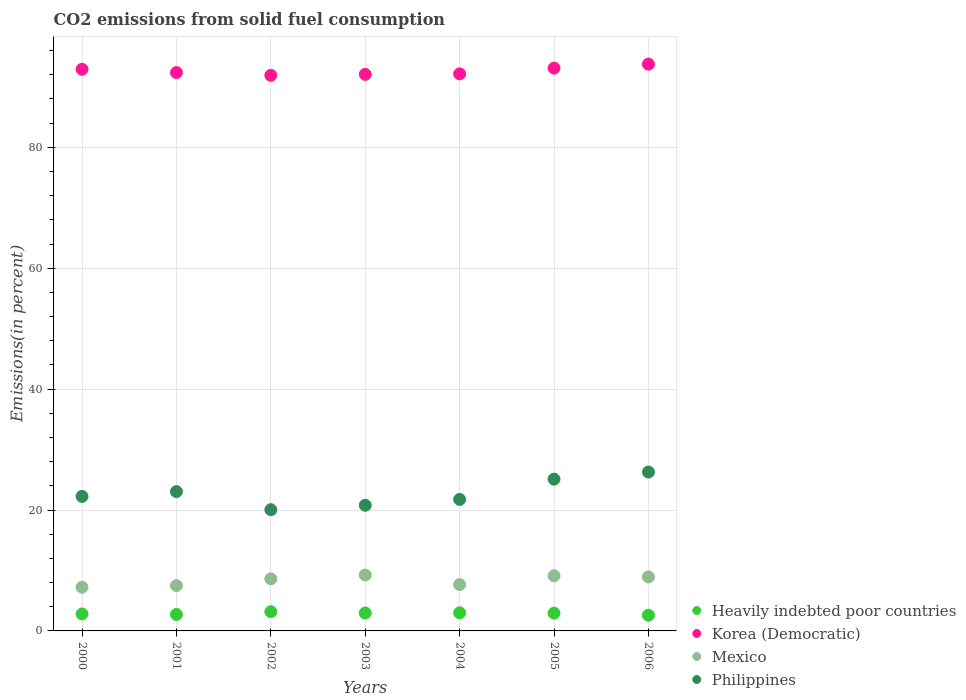How many different coloured dotlines are there?
Make the answer very short. 4. Is the number of dotlines equal to the number of legend labels?
Provide a succinct answer. Yes. What is the total CO2 emitted in Korea (Democratic) in 2002?
Keep it short and to the point. 91.92. Across all years, what is the maximum total CO2 emitted in Philippines?
Provide a succinct answer. 26.29. Across all years, what is the minimum total CO2 emitted in Philippines?
Your answer should be very brief. 20.06. What is the total total CO2 emitted in Philippines in the graph?
Your answer should be very brief. 159.3. What is the difference between the total CO2 emitted in Heavily indebted poor countries in 2001 and that in 2004?
Keep it short and to the point. -0.27. What is the difference between the total CO2 emitted in Heavily indebted poor countries in 2005 and the total CO2 emitted in Mexico in 2000?
Keep it short and to the point. -4.29. What is the average total CO2 emitted in Mexico per year?
Offer a very short reply. 8.33. In the year 2002, what is the difference between the total CO2 emitted in Philippines and total CO2 emitted in Mexico?
Offer a terse response. 11.44. What is the ratio of the total CO2 emitted in Heavily indebted poor countries in 2000 to that in 2003?
Your response must be concise. 0.95. What is the difference between the highest and the second highest total CO2 emitted in Korea (Democratic)?
Your answer should be very brief. 0.66. What is the difference between the highest and the lowest total CO2 emitted in Heavily indebted poor countries?
Make the answer very short. 0.58. Is the sum of the total CO2 emitted in Korea (Democratic) in 2001 and 2003 greater than the maximum total CO2 emitted in Heavily indebted poor countries across all years?
Give a very brief answer. Yes. Is it the case that in every year, the sum of the total CO2 emitted in Mexico and total CO2 emitted in Heavily indebted poor countries  is greater than the sum of total CO2 emitted in Philippines and total CO2 emitted in Korea (Democratic)?
Your answer should be very brief. No. Is the total CO2 emitted in Heavily indebted poor countries strictly greater than the total CO2 emitted in Korea (Democratic) over the years?
Offer a very short reply. No. Is the total CO2 emitted in Heavily indebted poor countries strictly less than the total CO2 emitted in Mexico over the years?
Give a very brief answer. Yes. What is the difference between two consecutive major ticks on the Y-axis?
Keep it short and to the point. 20. Are the values on the major ticks of Y-axis written in scientific E-notation?
Provide a succinct answer. No. How many legend labels are there?
Offer a terse response. 4. What is the title of the graph?
Your response must be concise. CO2 emissions from solid fuel consumption. Does "Nepal" appear as one of the legend labels in the graph?
Your answer should be compact. No. What is the label or title of the Y-axis?
Keep it short and to the point. Emissions(in percent). What is the Emissions(in percent) of Heavily indebted poor countries in 2000?
Provide a succinct answer. 2.81. What is the Emissions(in percent) of Korea (Democratic) in 2000?
Make the answer very short. 92.91. What is the Emissions(in percent) in Mexico in 2000?
Your response must be concise. 7.23. What is the Emissions(in percent) of Philippines in 2000?
Keep it short and to the point. 22.26. What is the Emissions(in percent) in Heavily indebted poor countries in 2001?
Your answer should be very brief. 2.73. What is the Emissions(in percent) in Korea (Democratic) in 2001?
Offer a terse response. 92.37. What is the Emissions(in percent) in Mexico in 2001?
Your answer should be very brief. 7.5. What is the Emissions(in percent) in Philippines in 2001?
Provide a succinct answer. 23.05. What is the Emissions(in percent) of Heavily indebted poor countries in 2002?
Your response must be concise. 3.18. What is the Emissions(in percent) in Korea (Democratic) in 2002?
Provide a short and direct response. 91.92. What is the Emissions(in percent) of Mexico in 2002?
Keep it short and to the point. 8.62. What is the Emissions(in percent) in Philippines in 2002?
Keep it short and to the point. 20.06. What is the Emissions(in percent) in Heavily indebted poor countries in 2003?
Offer a terse response. 2.97. What is the Emissions(in percent) of Korea (Democratic) in 2003?
Provide a short and direct response. 92.07. What is the Emissions(in percent) in Mexico in 2003?
Your response must be concise. 9.24. What is the Emissions(in percent) in Philippines in 2003?
Your response must be concise. 20.79. What is the Emissions(in percent) in Heavily indebted poor countries in 2004?
Make the answer very short. 3. What is the Emissions(in percent) of Korea (Democratic) in 2004?
Offer a very short reply. 92.15. What is the Emissions(in percent) of Mexico in 2004?
Offer a terse response. 7.66. What is the Emissions(in percent) of Philippines in 2004?
Keep it short and to the point. 21.75. What is the Emissions(in percent) in Heavily indebted poor countries in 2005?
Offer a terse response. 2.94. What is the Emissions(in percent) of Korea (Democratic) in 2005?
Give a very brief answer. 93.11. What is the Emissions(in percent) of Mexico in 2005?
Offer a terse response. 9.12. What is the Emissions(in percent) of Philippines in 2005?
Give a very brief answer. 25.11. What is the Emissions(in percent) of Heavily indebted poor countries in 2006?
Keep it short and to the point. 2.6. What is the Emissions(in percent) in Korea (Democratic) in 2006?
Provide a short and direct response. 93.77. What is the Emissions(in percent) in Mexico in 2006?
Your answer should be very brief. 8.93. What is the Emissions(in percent) in Philippines in 2006?
Offer a very short reply. 26.29. Across all years, what is the maximum Emissions(in percent) in Heavily indebted poor countries?
Offer a terse response. 3.18. Across all years, what is the maximum Emissions(in percent) of Korea (Democratic)?
Provide a succinct answer. 93.77. Across all years, what is the maximum Emissions(in percent) in Mexico?
Provide a succinct answer. 9.24. Across all years, what is the maximum Emissions(in percent) in Philippines?
Provide a succinct answer. 26.29. Across all years, what is the minimum Emissions(in percent) in Heavily indebted poor countries?
Your answer should be compact. 2.6. Across all years, what is the minimum Emissions(in percent) of Korea (Democratic)?
Provide a succinct answer. 91.92. Across all years, what is the minimum Emissions(in percent) of Mexico?
Provide a short and direct response. 7.23. Across all years, what is the minimum Emissions(in percent) in Philippines?
Provide a succinct answer. 20.06. What is the total Emissions(in percent) of Heavily indebted poor countries in the graph?
Provide a succinct answer. 20.22. What is the total Emissions(in percent) in Korea (Democratic) in the graph?
Provide a succinct answer. 648.3. What is the total Emissions(in percent) in Mexico in the graph?
Offer a terse response. 58.31. What is the total Emissions(in percent) in Philippines in the graph?
Make the answer very short. 159.3. What is the difference between the Emissions(in percent) of Heavily indebted poor countries in 2000 and that in 2001?
Your answer should be compact. 0.08. What is the difference between the Emissions(in percent) in Korea (Democratic) in 2000 and that in 2001?
Provide a short and direct response. 0.55. What is the difference between the Emissions(in percent) of Mexico in 2000 and that in 2001?
Your response must be concise. -0.27. What is the difference between the Emissions(in percent) in Philippines in 2000 and that in 2001?
Your response must be concise. -0.79. What is the difference between the Emissions(in percent) of Heavily indebted poor countries in 2000 and that in 2002?
Give a very brief answer. -0.37. What is the difference between the Emissions(in percent) in Korea (Democratic) in 2000 and that in 2002?
Your answer should be very brief. 1. What is the difference between the Emissions(in percent) in Mexico in 2000 and that in 2002?
Give a very brief answer. -1.39. What is the difference between the Emissions(in percent) in Philippines in 2000 and that in 2002?
Offer a terse response. 2.2. What is the difference between the Emissions(in percent) of Heavily indebted poor countries in 2000 and that in 2003?
Provide a short and direct response. -0.16. What is the difference between the Emissions(in percent) of Korea (Democratic) in 2000 and that in 2003?
Your answer should be very brief. 0.84. What is the difference between the Emissions(in percent) of Mexico in 2000 and that in 2003?
Your answer should be very brief. -2.01. What is the difference between the Emissions(in percent) in Philippines in 2000 and that in 2003?
Provide a short and direct response. 1.47. What is the difference between the Emissions(in percent) in Heavily indebted poor countries in 2000 and that in 2004?
Your response must be concise. -0.19. What is the difference between the Emissions(in percent) of Korea (Democratic) in 2000 and that in 2004?
Keep it short and to the point. 0.76. What is the difference between the Emissions(in percent) in Mexico in 2000 and that in 2004?
Give a very brief answer. -0.43. What is the difference between the Emissions(in percent) of Philippines in 2000 and that in 2004?
Provide a succinct answer. 0.5. What is the difference between the Emissions(in percent) of Heavily indebted poor countries in 2000 and that in 2005?
Your answer should be compact. -0.13. What is the difference between the Emissions(in percent) of Korea (Democratic) in 2000 and that in 2005?
Your response must be concise. -0.19. What is the difference between the Emissions(in percent) of Mexico in 2000 and that in 2005?
Your answer should be very brief. -1.89. What is the difference between the Emissions(in percent) in Philippines in 2000 and that in 2005?
Provide a succinct answer. -2.85. What is the difference between the Emissions(in percent) in Heavily indebted poor countries in 2000 and that in 2006?
Offer a terse response. 0.21. What is the difference between the Emissions(in percent) of Korea (Democratic) in 2000 and that in 2006?
Provide a succinct answer. -0.85. What is the difference between the Emissions(in percent) in Mexico in 2000 and that in 2006?
Your response must be concise. -1.7. What is the difference between the Emissions(in percent) in Philippines in 2000 and that in 2006?
Make the answer very short. -4.03. What is the difference between the Emissions(in percent) in Heavily indebted poor countries in 2001 and that in 2002?
Make the answer very short. -0.46. What is the difference between the Emissions(in percent) of Korea (Democratic) in 2001 and that in 2002?
Your response must be concise. 0.45. What is the difference between the Emissions(in percent) in Mexico in 2001 and that in 2002?
Your answer should be very brief. -1.12. What is the difference between the Emissions(in percent) in Philippines in 2001 and that in 2002?
Provide a succinct answer. 2.99. What is the difference between the Emissions(in percent) of Heavily indebted poor countries in 2001 and that in 2003?
Give a very brief answer. -0.24. What is the difference between the Emissions(in percent) of Korea (Democratic) in 2001 and that in 2003?
Keep it short and to the point. 0.29. What is the difference between the Emissions(in percent) of Mexico in 2001 and that in 2003?
Offer a very short reply. -1.75. What is the difference between the Emissions(in percent) in Philippines in 2001 and that in 2003?
Offer a terse response. 2.26. What is the difference between the Emissions(in percent) in Heavily indebted poor countries in 2001 and that in 2004?
Provide a succinct answer. -0.27. What is the difference between the Emissions(in percent) in Korea (Democratic) in 2001 and that in 2004?
Give a very brief answer. 0.22. What is the difference between the Emissions(in percent) in Mexico in 2001 and that in 2004?
Keep it short and to the point. -0.17. What is the difference between the Emissions(in percent) of Philippines in 2001 and that in 2004?
Offer a terse response. 1.29. What is the difference between the Emissions(in percent) of Heavily indebted poor countries in 2001 and that in 2005?
Offer a terse response. -0.21. What is the difference between the Emissions(in percent) of Korea (Democratic) in 2001 and that in 2005?
Give a very brief answer. -0.74. What is the difference between the Emissions(in percent) in Mexico in 2001 and that in 2005?
Keep it short and to the point. -1.62. What is the difference between the Emissions(in percent) of Philippines in 2001 and that in 2005?
Your response must be concise. -2.06. What is the difference between the Emissions(in percent) of Heavily indebted poor countries in 2001 and that in 2006?
Your response must be concise. 0.13. What is the difference between the Emissions(in percent) in Korea (Democratic) in 2001 and that in 2006?
Ensure brevity in your answer.  -1.4. What is the difference between the Emissions(in percent) of Mexico in 2001 and that in 2006?
Give a very brief answer. -1.44. What is the difference between the Emissions(in percent) of Philippines in 2001 and that in 2006?
Your response must be concise. -3.24. What is the difference between the Emissions(in percent) of Heavily indebted poor countries in 2002 and that in 2003?
Provide a short and direct response. 0.21. What is the difference between the Emissions(in percent) in Korea (Democratic) in 2002 and that in 2003?
Provide a short and direct response. -0.16. What is the difference between the Emissions(in percent) in Mexico in 2002 and that in 2003?
Offer a terse response. -0.62. What is the difference between the Emissions(in percent) in Philippines in 2002 and that in 2003?
Your answer should be very brief. -0.73. What is the difference between the Emissions(in percent) in Heavily indebted poor countries in 2002 and that in 2004?
Provide a succinct answer. 0.18. What is the difference between the Emissions(in percent) of Korea (Democratic) in 2002 and that in 2004?
Give a very brief answer. -0.24. What is the difference between the Emissions(in percent) in Mexico in 2002 and that in 2004?
Make the answer very short. 0.96. What is the difference between the Emissions(in percent) in Philippines in 2002 and that in 2004?
Offer a terse response. -1.7. What is the difference between the Emissions(in percent) in Heavily indebted poor countries in 2002 and that in 2005?
Make the answer very short. 0.24. What is the difference between the Emissions(in percent) in Korea (Democratic) in 2002 and that in 2005?
Your response must be concise. -1.19. What is the difference between the Emissions(in percent) in Mexico in 2002 and that in 2005?
Your answer should be very brief. -0.5. What is the difference between the Emissions(in percent) of Philippines in 2002 and that in 2005?
Keep it short and to the point. -5.05. What is the difference between the Emissions(in percent) of Heavily indebted poor countries in 2002 and that in 2006?
Ensure brevity in your answer.  0.58. What is the difference between the Emissions(in percent) in Korea (Democratic) in 2002 and that in 2006?
Offer a very short reply. -1.85. What is the difference between the Emissions(in percent) of Mexico in 2002 and that in 2006?
Keep it short and to the point. -0.31. What is the difference between the Emissions(in percent) of Philippines in 2002 and that in 2006?
Your answer should be very brief. -6.23. What is the difference between the Emissions(in percent) in Heavily indebted poor countries in 2003 and that in 2004?
Your response must be concise. -0.03. What is the difference between the Emissions(in percent) in Korea (Democratic) in 2003 and that in 2004?
Give a very brief answer. -0.08. What is the difference between the Emissions(in percent) in Mexico in 2003 and that in 2004?
Offer a terse response. 1.58. What is the difference between the Emissions(in percent) of Philippines in 2003 and that in 2004?
Make the answer very short. -0.97. What is the difference between the Emissions(in percent) of Heavily indebted poor countries in 2003 and that in 2005?
Your answer should be compact. 0.03. What is the difference between the Emissions(in percent) of Korea (Democratic) in 2003 and that in 2005?
Offer a terse response. -1.03. What is the difference between the Emissions(in percent) of Mexico in 2003 and that in 2005?
Ensure brevity in your answer.  0.12. What is the difference between the Emissions(in percent) of Philippines in 2003 and that in 2005?
Ensure brevity in your answer.  -4.32. What is the difference between the Emissions(in percent) of Heavily indebted poor countries in 2003 and that in 2006?
Provide a succinct answer. 0.37. What is the difference between the Emissions(in percent) of Korea (Democratic) in 2003 and that in 2006?
Your answer should be compact. -1.69. What is the difference between the Emissions(in percent) in Mexico in 2003 and that in 2006?
Give a very brief answer. 0.31. What is the difference between the Emissions(in percent) in Philippines in 2003 and that in 2006?
Offer a very short reply. -5.5. What is the difference between the Emissions(in percent) in Heavily indebted poor countries in 2004 and that in 2005?
Offer a very short reply. 0.06. What is the difference between the Emissions(in percent) of Korea (Democratic) in 2004 and that in 2005?
Provide a short and direct response. -0.96. What is the difference between the Emissions(in percent) of Mexico in 2004 and that in 2005?
Your response must be concise. -1.46. What is the difference between the Emissions(in percent) of Philippines in 2004 and that in 2005?
Keep it short and to the point. -3.35. What is the difference between the Emissions(in percent) of Heavily indebted poor countries in 2004 and that in 2006?
Keep it short and to the point. 0.4. What is the difference between the Emissions(in percent) in Korea (Democratic) in 2004 and that in 2006?
Give a very brief answer. -1.62. What is the difference between the Emissions(in percent) in Mexico in 2004 and that in 2006?
Offer a very short reply. -1.27. What is the difference between the Emissions(in percent) of Philippines in 2004 and that in 2006?
Your answer should be compact. -4.53. What is the difference between the Emissions(in percent) in Heavily indebted poor countries in 2005 and that in 2006?
Offer a terse response. 0.34. What is the difference between the Emissions(in percent) of Korea (Democratic) in 2005 and that in 2006?
Keep it short and to the point. -0.66. What is the difference between the Emissions(in percent) of Mexico in 2005 and that in 2006?
Give a very brief answer. 0.19. What is the difference between the Emissions(in percent) of Philippines in 2005 and that in 2006?
Keep it short and to the point. -1.18. What is the difference between the Emissions(in percent) in Heavily indebted poor countries in 2000 and the Emissions(in percent) in Korea (Democratic) in 2001?
Your answer should be compact. -89.56. What is the difference between the Emissions(in percent) of Heavily indebted poor countries in 2000 and the Emissions(in percent) of Mexico in 2001?
Ensure brevity in your answer.  -4.69. What is the difference between the Emissions(in percent) of Heavily indebted poor countries in 2000 and the Emissions(in percent) of Philippines in 2001?
Ensure brevity in your answer.  -20.24. What is the difference between the Emissions(in percent) of Korea (Democratic) in 2000 and the Emissions(in percent) of Mexico in 2001?
Give a very brief answer. 85.42. What is the difference between the Emissions(in percent) in Korea (Democratic) in 2000 and the Emissions(in percent) in Philippines in 2001?
Your answer should be very brief. 69.87. What is the difference between the Emissions(in percent) in Mexico in 2000 and the Emissions(in percent) in Philippines in 2001?
Your answer should be compact. -15.82. What is the difference between the Emissions(in percent) in Heavily indebted poor countries in 2000 and the Emissions(in percent) in Korea (Democratic) in 2002?
Offer a terse response. -89.11. What is the difference between the Emissions(in percent) of Heavily indebted poor countries in 2000 and the Emissions(in percent) of Mexico in 2002?
Provide a succinct answer. -5.81. What is the difference between the Emissions(in percent) in Heavily indebted poor countries in 2000 and the Emissions(in percent) in Philippines in 2002?
Your answer should be very brief. -17.25. What is the difference between the Emissions(in percent) in Korea (Democratic) in 2000 and the Emissions(in percent) in Mexico in 2002?
Offer a terse response. 84.29. What is the difference between the Emissions(in percent) of Korea (Democratic) in 2000 and the Emissions(in percent) of Philippines in 2002?
Ensure brevity in your answer.  72.86. What is the difference between the Emissions(in percent) in Mexico in 2000 and the Emissions(in percent) in Philippines in 2002?
Your answer should be compact. -12.83. What is the difference between the Emissions(in percent) of Heavily indebted poor countries in 2000 and the Emissions(in percent) of Korea (Democratic) in 2003?
Your answer should be very brief. -89.27. What is the difference between the Emissions(in percent) in Heavily indebted poor countries in 2000 and the Emissions(in percent) in Mexico in 2003?
Your answer should be compact. -6.44. What is the difference between the Emissions(in percent) of Heavily indebted poor countries in 2000 and the Emissions(in percent) of Philippines in 2003?
Your response must be concise. -17.98. What is the difference between the Emissions(in percent) in Korea (Democratic) in 2000 and the Emissions(in percent) in Mexico in 2003?
Your response must be concise. 83.67. What is the difference between the Emissions(in percent) in Korea (Democratic) in 2000 and the Emissions(in percent) in Philippines in 2003?
Offer a very short reply. 72.13. What is the difference between the Emissions(in percent) of Mexico in 2000 and the Emissions(in percent) of Philippines in 2003?
Your answer should be compact. -13.56. What is the difference between the Emissions(in percent) of Heavily indebted poor countries in 2000 and the Emissions(in percent) of Korea (Democratic) in 2004?
Offer a terse response. -89.34. What is the difference between the Emissions(in percent) of Heavily indebted poor countries in 2000 and the Emissions(in percent) of Mexico in 2004?
Your response must be concise. -4.85. What is the difference between the Emissions(in percent) in Heavily indebted poor countries in 2000 and the Emissions(in percent) in Philippines in 2004?
Make the answer very short. -18.95. What is the difference between the Emissions(in percent) of Korea (Democratic) in 2000 and the Emissions(in percent) of Mexico in 2004?
Provide a succinct answer. 85.25. What is the difference between the Emissions(in percent) of Korea (Democratic) in 2000 and the Emissions(in percent) of Philippines in 2004?
Your answer should be very brief. 71.16. What is the difference between the Emissions(in percent) of Mexico in 2000 and the Emissions(in percent) of Philippines in 2004?
Offer a very short reply. -14.52. What is the difference between the Emissions(in percent) in Heavily indebted poor countries in 2000 and the Emissions(in percent) in Korea (Democratic) in 2005?
Give a very brief answer. -90.3. What is the difference between the Emissions(in percent) in Heavily indebted poor countries in 2000 and the Emissions(in percent) in Mexico in 2005?
Offer a very short reply. -6.31. What is the difference between the Emissions(in percent) of Heavily indebted poor countries in 2000 and the Emissions(in percent) of Philippines in 2005?
Make the answer very short. -22.3. What is the difference between the Emissions(in percent) of Korea (Democratic) in 2000 and the Emissions(in percent) of Mexico in 2005?
Offer a terse response. 83.79. What is the difference between the Emissions(in percent) in Korea (Democratic) in 2000 and the Emissions(in percent) in Philippines in 2005?
Give a very brief answer. 67.81. What is the difference between the Emissions(in percent) in Mexico in 2000 and the Emissions(in percent) in Philippines in 2005?
Your answer should be very brief. -17.88. What is the difference between the Emissions(in percent) of Heavily indebted poor countries in 2000 and the Emissions(in percent) of Korea (Democratic) in 2006?
Your answer should be compact. -90.96. What is the difference between the Emissions(in percent) of Heavily indebted poor countries in 2000 and the Emissions(in percent) of Mexico in 2006?
Your answer should be compact. -6.13. What is the difference between the Emissions(in percent) of Heavily indebted poor countries in 2000 and the Emissions(in percent) of Philippines in 2006?
Offer a terse response. -23.48. What is the difference between the Emissions(in percent) in Korea (Democratic) in 2000 and the Emissions(in percent) in Mexico in 2006?
Keep it short and to the point. 83.98. What is the difference between the Emissions(in percent) of Korea (Democratic) in 2000 and the Emissions(in percent) of Philippines in 2006?
Offer a terse response. 66.63. What is the difference between the Emissions(in percent) in Mexico in 2000 and the Emissions(in percent) in Philippines in 2006?
Offer a very short reply. -19.06. What is the difference between the Emissions(in percent) in Heavily indebted poor countries in 2001 and the Emissions(in percent) in Korea (Democratic) in 2002?
Give a very brief answer. -89.19. What is the difference between the Emissions(in percent) in Heavily indebted poor countries in 2001 and the Emissions(in percent) in Mexico in 2002?
Your answer should be very brief. -5.89. What is the difference between the Emissions(in percent) in Heavily indebted poor countries in 2001 and the Emissions(in percent) in Philippines in 2002?
Provide a short and direct response. -17.33. What is the difference between the Emissions(in percent) in Korea (Democratic) in 2001 and the Emissions(in percent) in Mexico in 2002?
Keep it short and to the point. 83.75. What is the difference between the Emissions(in percent) in Korea (Democratic) in 2001 and the Emissions(in percent) in Philippines in 2002?
Provide a succinct answer. 72.31. What is the difference between the Emissions(in percent) in Mexico in 2001 and the Emissions(in percent) in Philippines in 2002?
Make the answer very short. -12.56. What is the difference between the Emissions(in percent) of Heavily indebted poor countries in 2001 and the Emissions(in percent) of Korea (Democratic) in 2003?
Offer a very short reply. -89.35. What is the difference between the Emissions(in percent) of Heavily indebted poor countries in 2001 and the Emissions(in percent) of Mexico in 2003?
Ensure brevity in your answer.  -6.52. What is the difference between the Emissions(in percent) in Heavily indebted poor countries in 2001 and the Emissions(in percent) in Philippines in 2003?
Ensure brevity in your answer.  -18.06. What is the difference between the Emissions(in percent) of Korea (Democratic) in 2001 and the Emissions(in percent) of Mexico in 2003?
Your response must be concise. 83.12. What is the difference between the Emissions(in percent) of Korea (Democratic) in 2001 and the Emissions(in percent) of Philippines in 2003?
Keep it short and to the point. 71.58. What is the difference between the Emissions(in percent) in Mexico in 2001 and the Emissions(in percent) in Philippines in 2003?
Ensure brevity in your answer.  -13.29. What is the difference between the Emissions(in percent) in Heavily indebted poor countries in 2001 and the Emissions(in percent) in Korea (Democratic) in 2004?
Offer a terse response. -89.43. What is the difference between the Emissions(in percent) of Heavily indebted poor countries in 2001 and the Emissions(in percent) of Mexico in 2004?
Provide a succinct answer. -4.94. What is the difference between the Emissions(in percent) of Heavily indebted poor countries in 2001 and the Emissions(in percent) of Philippines in 2004?
Give a very brief answer. -19.03. What is the difference between the Emissions(in percent) in Korea (Democratic) in 2001 and the Emissions(in percent) in Mexico in 2004?
Ensure brevity in your answer.  84.71. What is the difference between the Emissions(in percent) of Korea (Democratic) in 2001 and the Emissions(in percent) of Philippines in 2004?
Ensure brevity in your answer.  70.61. What is the difference between the Emissions(in percent) of Mexico in 2001 and the Emissions(in percent) of Philippines in 2004?
Provide a short and direct response. -14.26. What is the difference between the Emissions(in percent) in Heavily indebted poor countries in 2001 and the Emissions(in percent) in Korea (Democratic) in 2005?
Offer a very short reply. -90.38. What is the difference between the Emissions(in percent) in Heavily indebted poor countries in 2001 and the Emissions(in percent) in Mexico in 2005?
Provide a short and direct response. -6.39. What is the difference between the Emissions(in percent) in Heavily indebted poor countries in 2001 and the Emissions(in percent) in Philippines in 2005?
Your answer should be very brief. -22.38. What is the difference between the Emissions(in percent) of Korea (Democratic) in 2001 and the Emissions(in percent) of Mexico in 2005?
Offer a very short reply. 83.25. What is the difference between the Emissions(in percent) in Korea (Democratic) in 2001 and the Emissions(in percent) in Philippines in 2005?
Ensure brevity in your answer.  67.26. What is the difference between the Emissions(in percent) of Mexico in 2001 and the Emissions(in percent) of Philippines in 2005?
Offer a very short reply. -17.61. What is the difference between the Emissions(in percent) in Heavily indebted poor countries in 2001 and the Emissions(in percent) in Korea (Democratic) in 2006?
Keep it short and to the point. -91.04. What is the difference between the Emissions(in percent) in Heavily indebted poor countries in 2001 and the Emissions(in percent) in Mexico in 2006?
Provide a succinct answer. -6.21. What is the difference between the Emissions(in percent) in Heavily indebted poor countries in 2001 and the Emissions(in percent) in Philippines in 2006?
Offer a very short reply. -23.56. What is the difference between the Emissions(in percent) in Korea (Democratic) in 2001 and the Emissions(in percent) in Mexico in 2006?
Ensure brevity in your answer.  83.44. What is the difference between the Emissions(in percent) in Korea (Democratic) in 2001 and the Emissions(in percent) in Philippines in 2006?
Provide a succinct answer. 66.08. What is the difference between the Emissions(in percent) of Mexico in 2001 and the Emissions(in percent) of Philippines in 2006?
Give a very brief answer. -18.79. What is the difference between the Emissions(in percent) of Heavily indebted poor countries in 2002 and the Emissions(in percent) of Korea (Democratic) in 2003?
Your answer should be very brief. -88.89. What is the difference between the Emissions(in percent) in Heavily indebted poor countries in 2002 and the Emissions(in percent) in Mexico in 2003?
Provide a succinct answer. -6.06. What is the difference between the Emissions(in percent) of Heavily indebted poor countries in 2002 and the Emissions(in percent) of Philippines in 2003?
Provide a succinct answer. -17.61. What is the difference between the Emissions(in percent) in Korea (Democratic) in 2002 and the Emissions(in percent) in Mexico in 2003?
Offer a terse response. 82.67. What is the difference between the Emissions(in percent) in Korea (Democratic) in 2002 and the Emissions(in percent) in Philippines in 2003?
Your answer should be very brief. 71.13. What is the difference between the Emissions(in percent) of Mexico in 2002 and the Emissions(in percent) of Philippines in 2003?
Your response must be concise. -12.17. What is the difference between the Emissions(in percent) of Heavily indebted poor countries in 2002 and the Emissions(in percent) of Korea (Democratic) in 2004?
Provide a succinct answer. -88.97. What is the difference between the Emissions(in percent) in Heavily indebted poor countries in 2002 and the Emissions(in percent) in Mexico in 2004?
Give a very brief answer. -4.48. What is the difference between the Emissions(in percent) in Heavily indebted poor countries in 2002 and the Emissions(in percent) in Philippines in 2004?
Your answer should be compact. -18.57. What is the difference between the Emissions(in percent) in Korea (Democratic) in 2002 and the Emissions(in percent) in Mexico in 2004?
Keep it short and to the point. 84.25. What is the difference between the Emissions(in percent) of Korea (Democratic) in 2002 and the Emissions(in percent) of Philippines in 2004?
Provide a succinct answer. 70.16. What is the difference between the Emissions(in percent) of Mexico in 2002 and the Emissions(in percent) of Philippines in 2004?
Offer a very short reply. -13.13. What is the difference between the Emissions(in percent) in Heavily indebted poor countries in 2002 and the Emissions(in percent) in Korea (Democratic) in 2005?
Ensure brevity in your answer.  -89.93. What is the difference between the Emissions(in percent) of Heavily indebted poor countries in 2002 and the Emissions(in percent) of Mexico in 2005?
Your response must be concise. -5.94. What is the difference between the Emissions(in percent) in Heavily indebted poor countries in 2002 and the Emissions(in percent) in Philippines in 2005?
Your answer should be compact. -21.93. What is the difference between the Emissions(in percent) of Korea (Democratic) in 2002 and the Emissions(in percent) of Mexico in 2005?
Provide a succinct answer. 82.79. What is the difference between the Emissions(in percent) of Korea (Democratic) in 2002 and the Emissions(in percent) of Philippines in 2005?
Offer a terse response. 66.81. What is the difference between the Emissions(in percent) of Mexico in 2002 and the Emissions(in percent) of Philippines in 2005?
Give a very brief answer. -16.49. What is the difference between the Emissions(in percent) of Heavily indebted poor countries in 2002 and the Emissions(in percent) of Korea (Democratic) in 2006?
Provide a succinct answer. -90.59. What is the difference between the Emissions(in percent) in Heavily indebted poor countries in 2002 and the Emissions(in percent) in Mexico in 2006?
Your answer should be compact. -5.75. What is the difference between the Emissions(in percent) of Heavily indebted poor countries in 2002 and the Emissions(in percent) of Philippines in 2006?
Give a very brief answer. -23.11. What is the difference between the Emissions(in percent) in Korea (Democratic) in 2002 and the Emissions(in percent) in Mexico in 2006?
Offer a terse response. 82.98. What is the difference between the Emissions(in percent) of Korea (Democratic) in 2002 and the Emissions(in percent) of Philippines in 2006?
Offer a very short reply. 65.63. What is the difference between the Emissions(in percent) in Mexico in 2002 and the Emissions(in percent) in Philippines in 2006?
Your answer should be compact. -17.67. What is the difference between the Emissions(in percent) in Heavily indebted poor countries in 2003 and the Emissions(in percent) in Korea (Democratic) in 2004?
Give a very brief answer. -89.18. What is the difference between the Emissions(in percent) of Heavily indebted poor countries in 2003 and the Emissions(in percent) of Mexico in 2004?
Keep it short and to the point. -4.69. What is the difference between the Emissions(in percent) of Heavily indebted poor countries in 2003 and the Emissions(in percent) of Philippines in 2004?
Offer a very short reply. -18.79. What is the difference between the Emissions(in percent) in Korea (Democratic) in 2003 and the Emissions(in percent) in Mexico in 2004?
Ensure brevity in your answer.  84.41. What is the difference between the Emissions(in percent) of Korea (Democratic) in 2003 and the Emissions(in percent) of Philippines in 2004?
Provide a short and direct response. 70.32. What is the difference between the Emissions(in percent) of Mexico in 2003 and the Emissions(in percent) of Philippines in 2004?
Give a very brief answer. -12.51. What is the difference between the Emissions(in percent) of Heavily indebted poor countries in 2003 and the Emissions(in percent) of Korea (Democratic) in 2005?
Provide a succinct answer. -90.14. What is the difference between the Emissions(in percent) of Heavily indebted poor countries in 2003 and the Emissions(in percent) of Mexico in 2005?
Offer a very short reply. -6.15. What is the difference between the Emissions(in percent) in Heavily indebted poor countries in 2003 and the Emissions(in percent) in Philippines in 2005?
Provide a succinct answer. -22.14. What is the difference between the Emissions(in percent) in Korea (Democratic) in 2003 and the Emissions(in percent) in Mexico in 2005?
Keep it short and to the point. 82.95. What is the difference between the Emissions(in percent) of Korea (Democratic) in 2003 and the Emissions(in percent) of Philippines in 2005?
Offer a terse response. 66.97. What is the difference between the Emissions(in percent) in Mexico in 2003 and the Emissions(in percent) in Philippines in 2005?
Provide a succinct answer. -15.86. What is the difference between the Emissions(in percent) of Heavily indebted poor countries in 2003 and the Emissions(in percent) of Korea (Democratic) in 2006?
Your response must be concise. -90.8. What is the difference between the Emissions(in percent) in Heavily indebted poor countries in 2003 and the Emissions(in percent) in Mexico in 2006?
Keep it short and to the point. -5.96. What is the difference between the Emissions(in percent) of Heavily indebted poor countries in 2003 and the Emissions(in percent) of Philippines in 2006?
Ensure brevity in your answer.  -23.32. What is the difference between the Emissions(in percent) in Korea (Democratic) in 2003 and the Emissions(in percent) in Mexico in 2006?
Provide a short and direct response. 83.14. What is the difference between the Emissions(in percent) in Korea (Democratic) in 2003 and the Emissions(in percent) in Philippines in 2006?
Offer a terse response. 65.79. What is the difference between the Emissions(in percent) in Mexico in 2003 and the Emissions(in percent) in Philippines in 2006?
Your answer should be very brief. -17.05. What is the difference between the Emissions(in percent) of Heavily indebted poor countries in 2004 and the Emissions(in percent) of Korea (Democratic) in 2005?
Keep it short and to the point. -90.11. What is the difference between the Emissions(in percent) of Heavily indebted poor countries in 2004 and the Emissions(in percent) of Mexico in 2005?
Provide a short and direct response. -6.12. What is the difference between the Emissions(in percent) in Heavily indebted poor countries in 2004 and the Emissions(in percent) in Philippines in 2005?
Ensure brevity in your answer.  -22.11. What is the difference between the Emissions(in percent) in Korea (Democratic) in 2004 and the Emissions(in percent) in Mexico in 2005?
Your answer should be very brief. 83.03. What is the difference between the Emissions(in percent) in Korea (Democratic) in 2004 and the Emissions(in percent) in Philippines in 2005?
Your answer should be very brief. 67.04. What is the difference between the Emissions(in percent) in Mexico in 2004 and the Emissions(in percent) in Philippines in 2005?
Ensure brevity in your answer.  -17.45. What is the difference between the Emissions(in percent) in Heavily indebted poor countries in 2004 and the Emissions(in percent) in Korea (Democratic) in 2006?
Your response must be concise. -90.77. What is the difference between the Emissions(in percent) of Heavily indebted poor countries in 2004 and the Emissions(in percent) of Mexico in 2006?
Keep it short and to the point. -5.94. What is the difference between the Emissions(in percent) in Heavily indebted poor countries in 2004 and the Emissions(in percent) in Philippines in 2006?
Make the answer very short. -23.29. What is the difference between the Emissions(in percent) in Korea (Democratic) in 2004 and the Emissions(in percent) in Mexico in 2006?
Offer a very short reply. 83.22. What is the difference between the Emissions(in percent) in Korea (Democratic) in 2004 and the Emissions(in percent) in Philippines in 2006?
Offer a terse response. 65.86. What is the difference between the Emissions(in percent) of Mexico in 2004 and the Emissions(in percent) of Philippines in 2006?
Ensure brevity in your answer.  -18.63. What is the difference between the Emissions(in percent) in Heavily indebted poor countries in 2005 and the Emissions(in percent) in Korea (Democratic) in 2006?
Your answer should be compact. -90.83. What is the difference between the Emissions(in percent) of Heavily indebted poor countries in 2005 and the Emissions(in percent) of Mexico in 2006?
Provide a short and direct response. -6. What is the difference between the Emissions(in percent) in Heavily indebted poor countries in 2005 and the Emissions(in percent) in Philippines in 2006?
Provide a short and direct response. -23.35. What is the difference between the Emissions(in percent) of Korea (Democratic) in 2005 and the Emissions(in percent) of Mexico in 2006?
Keep it short and to the point. 84.18. What is the difference between the Emissions(in percent) of Korea (Democratic) in 2005 and the Emissions(in percent) of Philippines in 2006?
Your answer should be compact. 66.82. What is the difference between the Emissions(in percent) in Mexico in 2005 and the Emissions(in percent) in Philippines in 2006?
Provide a succinct answer. -17.17. What is the average Emissions(in percent) in Heavily indebted poor countries per year?
Give a very brief answer. 2.89. What is the average Emissions(in percent) of Korea (Democratic) per year?
Keep it short and to the point. 92.61. What is the average Emissions(in percent) in Mexico per year?
Your answer should be very brief. 8.33. What is the average Emissions(in percent) in Philippines per year?
Offer a terse response. 22.76. In the year 2000, what is the difference between the Emissions(in percent) of Heavily indebted poor countries and Emissions(in percent) of Korea (Democratic)?
Your answer should be very brief. -90.11. In the year 2000, what is the difference between the Emissions(in percent) in Heavily indebted poor countries and Emissions(in percent) in Mexico?
Your answer should be compact. -4.42. In the year 2000, what is the difference between the Emissions(in percent) of Heavily indebted poor countries and Emissions(in percent) of Philippines?
Offer a very short reply. -19.45. In the year 2000, what is the difference between the Emissions(in percent) of Korea (Democratic) and Emissions(in percent) of Mexico?
Your response must be concise. 85.68. In the year 2000, what is the difference between the Emissions(in percent) in Korea (Democratic) and Emissions(in percent) in Philippines?
Ensure brevity in your answer.  70.66. In the year 2000, what is the difference between the Emissions(in percent) in Mexico and Emissions(in percent) in Philippines?
Keep it short and to the point. -15.02. In the year 2001, what is the difference between the Emissions(in percent) in Heavily indebted poor countries and Emissions(in percent) in Korea (Democratic)?
Give a very brief answer. -89.64. In the year 2001, what is the difference between the Emissions(in percent) of Heavily indebted poor countries and Emissions(in percent) of Mexico?
Make the answer very short. -4.77. In the year 2001, what is the difference between the Emissions(in percent) of Heavily indebted poor countries and Emissions(in percent) of Philippines?
Your answer should be compact. -20.32. In the year 2001, what is the difference between the Emissions(in percent) of Korea (Democratic) and Emissions(in percent) of Mexico?
Your answer should be very brief. 84.87. In the year 2001, what is the difference between the Emissions(in percent) in Korea (Democratic) and Emissions(in percent) in Philippines?
Your answer should be compact. 69.32. In the year 2001, what is the difference between the Emissions(in percent) of Mexico and Emissions(in percent) of Philippines?
Keep it short and to the point. -15.55. In the year 2002, what is the difference between the Emissions(in percent) in Heavily indebted poor countries and Emissions(in percent) in Korea (Democratic)?
Your response must be concise. -88.73. In the year 2002, what is the difference between the Emissions(in percent) in Heavily indebted poor countries and Emissions(in percent) in Mexico?
Give a very brief answer. -5.44. In the year 2002, what is the difference between the Emissions(in percent) of Heavily indebted poor countries and Emissions(in percent) of Philippines?
Offer a terse response. -16.88. In the year 2002, what is the difference between the Emissions(in percent) of Korea (Democratic) and Emissions(in percent) of Mexico?
Offer a terse response. 83.29. In the year 2002, what is the difference between the Emissions(in percent) of Korea (Democratic) and Emissions(in percent) of Philippines?
Give a very brief answer. 71.86. In the year 2002, what is the difference between the Emissions(in percent) of Mexico and Emissions(in percent) of Philippines?
Make the answer very short. -11.44. In the year 2003, what is the difference between the Emissions(in percent) of Heavily indebted poor countries and Emissions(in percent) of Korea (Democratic)?
Keep it short and to the point. -89.11. In the year 2003, what is the difference between the Emissions(in percent) of Heavily indebted poor countries and Emissions(in percent) of Mexico?
Give a very brief answer. -6.28. In the year 2003, what is the difference between the Emissions(in percent) in Heavily indebted poor countries and Emissions(in percent) in Philippines?
Keep it short and to the point. -17.82. In the year 2003, what is the difference between the Emissions(in percent) of Korea (Democratic) and Emissions(in percent) of Mexico?
Keep it short and to the point. 82.83. In the year 2003, what is the difference between the Emissions(in percent) in Korea (Democratic) and Emissions(in percent) in Philippines?
Your answer should be compact. 71.29. In the year 2003, what is the difference between the Emissions(in percent) in Mexico and Emissions(in percent) in Philippines?
Provide a succinct answer. -11.54. In the year 2004, what is the difference between the Emissions(in percent) of Heavily indebted poor countries and Emissions(in percent) of Korea (Democratic)?
Provide a short and direct response. -89.16. In the year 2004, what is the difference between the Emissions(in percent) in Heavily indebted poor countries and Emissions(in percent) in Mexico?
Ensure brevity in your answer.  -4.67. In the year 2004, what is the difference between the Emissions(in percent) in Heavily indebted poor countries and Emissions(in percent) in Philippines?
Your response must be concise. -18.76. In the year 2004, what is the difference between the Emissions(in percent) of Korea (Democratic) and Emissions(in percent) of Mexico?
Your response must be concise. 84.49. In the year 2004, what is the difference between the Emissions(in percent) of Korea (Democratic) and Emissions(in percent) of Philippines?
Offer a terse response. 70.4. In the year 2004, what is the difference between the Emissions(in percent) in Mexico and Emissions(in percent) in Philippines?
Offer a very short reply. -14.09. In the year 2005, what is the difference between the Emissions(in percent) in Heavily indebted poor countries and Emissions(in percent) in Korea (Democratic)?
Offer a terse response. -90.17. In the year 2005, what is the difference between the Emissions(in percent) of Heavily indebted poor countries and Emissions(in percent) of Mexico?
Your answer should be compact. -6.18. In the year 2005, what is the difference between the Emissions(in percent) of Heavily indebted poor countries and Emissions(in percent) of Philippines?
Your answer should be compact. -22.17. In the year 2005, what is the difference between the Emissions(in percent) in Korea (Democratic) and Emissions(in percent) in Mexico?
Your answer should be very brief. 83.99. In the year 2005, what is the difference between the Emissions(in percent) of Korea (Democratic) and Emissions(in percent) of Philippines?
Give a very brief answer. 68. In the year 2005, what is the difference between the Emissions(in percent) of Mexico and Emissions(in percent) of Philippines?
Ensure brevity in your answer.  -15.99. In the year 2006, what is the difference between the Emissions(in percent) of Heavily indebted poor countries and Emissions(in percent) of Korea (Democratic)?
Provide a short and direct response. -91.17. In the year 2006, what is the difference between the Emissions(in percent) in Heavily indebted poor countries and Emissions(in percent) in Mexico?
Provide a succinct answer. -6.33. In the year 2006, what is the difference between the Emissions(in percent) in Heavily indebted poor countries and Emissions(in percent) in Philippines?
Provide a short and direct response. -23.69. In the year 2006, what is the difference between the Emissions(in percent) in Korea (Democratic) and Emissions(in percent) in Mexico?
Your response must be concise. 84.83. In the year 2006, what is the difference between the Emissions(in percent) in Korea (Democratic) and Emissions(in percent) in Philippines?
Your response must be concise. 67.48. In the year 2006, what is the difference between the Emissions(in percent) in Mexico and Emissions(in percent) in Philippines?
Your response must be concise. -17.36. What is the ratio of the Emissions(in percent) in Heavily indebted poor countries in 2000 to that in 2001?
Provide a short and direct response. 1.03. What is the ratio of the Emissions(in percent) in Korea (Democratic) in 2000 to that in 2001?
Ensure brevity in your answer.  1.01. What is the ratio of the Emissions(in percent) in Mexico in 2000 to that in 2001?
Keep it short and to the point. 0.96. What is the ratio of the Emissions(in percent) in Philippines in 2000 to that in 2001?
Your answer should be very brief. 0.97. What is the ratio of the Emissions(in percent) in Heavily indebted poor countries in 2000 to that in 2002?
Offer a very short reply. 0.88. What is the ratio of the Emissions(in percent) of Korea (Democratic) in 2000 to that in 2002?
Ensure brevity in your answer.  1.01. What is the ratio of the Emissions(in percent) in Mexico in 2000 to that in 2002?
Offer a very short reply. 0.84. What is the ratio of the Emissions(in percent) of Philippines in 2000 to that in 2002?
Provide a succinct answer. 1.11. What is the ratio of the Emissions(in percent) in Heavily indebted poor countries in 2000 to that in 2003?
Your answer should be compact. 0.95. What is the ratio of the Emissions(in percent) in Korea (Democratic) in 2000 to that in 2003?
Your answer should be compact. 1.01. What is the ratio of the Emissions(in percent) in Mexico in 2000 to that in 2003?
Your answer should be very brief. 0.78. What is the ratio of the Emissions(in percent) of Philippines in 2000 to that in 2003?
Your answer should be compact. 1.07. What is the ratio of the Emissions(in percent) in Heavily indebted poor countries in 2000 to that in 2004?
Offer a terse response. 0.94. What is the ratio of the Emissions(in percent) in Korea (Democratic) in 2000 to that in 2004?
Your answer should be compact. 1.01. What is the ratio of the Emissions(in percent) in Mexico in 2000 to that in 2004?
Make the answer very short. 0.94. What is the ratio of the Emissions(in percent) of Philippines in 2000 to that in 2004?
Ensure brevity in your answer.  1.02. What is the ratio of the Emissions(in percent) in Heavily indebted poor countries in 2000 to that in 2005?
Provide a short and direct response. 0.96. What is the ratio of the Emissions(in percent) in Mexico in 2000 to that in 2005?
Your response must be concise. 0.79. What is the ratio of the Emissions(in percent) in Philippines in 2000 to that in 2005?
Make the answer very short. 0.89. What is the ratio of the Emissions(in percent) of Heavily indebted poor countries in 2000 to that in 2006?
Your answer should be compact. 1.08. What is the ratio of the Emissions(in percent) in Korea (Democratic) in 2000 to that in 2006?
Ensure brevity in your answer.  0.99. What is the ratio of the Emissions(in percent) of Mexico in 2000 to that in 2006?
Make the answer very short. 0.81. What is the ratio of the Emissions(in percent) in Philippines in 2000 to that in 2006?
Your answer should be very brief. 0.85. What is the ratio of the Emissions(in percent) in Heavily indebted poor countries in 2001 to that in 2002?
Give a very brief answer. 0.86. What is the ratio of the Emissions(in percent) of Korea (Democratic) in 2001 to that in 2002?
Ensure brevity in your answer.  1. What is the ratio of the Emissions(in percent) in Mexico in 2001 to that in 2002?
Your response must be concise. 0.87. What is the ratio of the Emissions(in percent) in Philippines in 2001 to that in 2002?
Your response must be concise. 1.15. What is the ratio of the Emissions(in percent) of Heavily indebted poor countries in 2001 to that in 2003?
Keep it short and to the point. 0.92. What is the ratio of the Emissions(in percent) of Korea (Democratic) in 2001 to that in 2003?
Your answer should be very brief. 1. What is the ratio of the Emissions(in percent) of Mexico in 2001 to that in 2003?
Your answer should be compact. 0.81. What is the ratio of the Emissions(in percent) of Philippines in 2001 to that in 2003?
Give a very brief answer. 1.11. What is the ratio of the Emissions(in percent) in Heavily indebted poor countries in 2001 to that in 2004?
Make the answer very short. 0.91. What is the ratio of the Emissions(in percent) of Korea (Democratic) in 2001 to that in 2004?
Offer a terse response. 1. What is the ratio of the Emissions(in percent) of Mexico in 2001 to that in 2004?
Your answer should be very brief. 0.98. What is the ratio of the Emissions(in percent) of Philippines in 2001 to that in 2004?
Your answer should be compact. 1.06. What is the ratio of the Emissions(in percent) of Heavily indebted poor countries in 2001 to that in 2005?
Offer a very short reply. 0.93. What is the ratio of the Emissions(in percent) of Korea (Democratic) in 2001 to that in 2005?
Provide a succinct answer. 0.99. What is the ratio of the Emissions(in percent) of Mexico in 2001 to that in 2005?
Offer a very short reply. 0.82. What is the ratio of the Emissions(in percent) in Philippines in 2001 to that in 2005?
Provide a succinct answer. 0.92. What is the ratio of the Emissions(in percent) of Heavily indebted poor countries in 2001 to that in 2006?
Give a very brief answer. 1.05. What is the ratio of the Emissions(in percent) in Korea (Democratic) in 2001 to that in 2006?
Your answer should be compact. 0.99. What is the ratio of the Emissions(in percent) of Mexico in 2001 to that in 2006?
Offer a terse response. 0.84. What is the ratio of the Emissions(in percent) of Philippines in 2001 to that in 2006?
Provide a short and direct response. 0.88. What is the ratio of the Emissions(in percent) of Heavily indebted poor countries in 2002 to that in 2003?
Offer a terse response. 1.07. What is the ratio of the Emissions(in percent) in Mexico in 2002 to that in 2003?
Make the answer very short. 0.93. What is the ratio of the Emissions(in percent) of Philippines in 2002 to that in 2003?
Your answer should be very brief. 0.96. What is the ratio of the Emissions(in percent) in Heavily indebted poor countries in 2002 to that in 2004?
Give a very brief answer. 1.06. What is the ratio of the Emissions(in percent) in Mexico in 2002 to that in 2004?
Provide a short and direct response. 1.13. What is the ratio of the Emissions(in percent) of Philippines in 2002 to that in 2004?
Your answer should be compact. 0.92. What is the ratio of the Emissions(in percent) in Heavily indebted poor countries in 2002 to that in 2005?
Keep it short and to the point. 1.08. What is the ratio of the Emissions(in percent) of Korea (Democratic) in 2002 to that in 2005?
Make the answer very short. 0.99. What is the ratio of the Emissions(in percent) in Mexico in 2002 to that in 2005?
Provide a succinct answer. 0.95. What is the ratio of the Emissions(in percent) of Philippines in 2002 to that in 2005?
Keep it short and to the point. 0.8. What is the ratio of the Emissions(in percent) in Heavily indebted poor countries in 2002 to that in 2006?
Your response must be concise. 1.22. What is the ratio of the Emissions(in percent) in Korea (Democratic) in 2002 to that in 2006?
Ensure brevity in your answer.  0.98. What is the ratio of the Emissions(in percent) of Philippines in 2002 to that in 2006?
Offer a terse response. 0.76. What is the ratio of the Emissions(in percent) of Korea (Democratic) in 2003 to that in 2004?
Make the answer very short. 1. What is the ratio of the Emissions(in percent) of Mexico in 2003 to that in 2004?
Your answer should be very brief. 1.21. What is the ratio of the Emissions(in percent) in Philippines in 2003 to that in 2004?
Give a very brief answer. 0.96. What is the ratio of the Emissions(in percent) in Heavily indebted poor countries in 2003 to that in 2005?
Offer a very short reply. 1.01. What is the ratio of the Emissions(in percent) of Korea (Democratic) in 2003 to that in 2005?
Give a very brief answer. 0.99. What is the ratio of the Emissions(in percent) of Mexico in 2003 to that in 2005?
Keep it short and to the point. 1.01. What is the ratio of the Emissions(in percent) of Philippines in 2003 to that in 2005?
Make the answer very short. 0.83. What is the ratio of the Emissions(in percent) in Heavily indebted poor countries in 2003 to that in 2006?
Ensure brevity in your answer.  1.14. What is the ratio of the Emissions(in percent) in Korea (Democratic) in 2003 to that in 2006?
Ensure brevity in your answer.  0.98. What is the ratio of the Emissions(in percent) of Mexico in 2003 to that in 2006?
Offer a terse response. 1.03. What is the ratio of the Emissions(in percent) of Philippines in 2003 to that in 2006?
Your answer should be compact. 0.79. What is the ratio of the Emissions(in percent) in Heavily indebted poor countries in 2004 to that in 2005?
Your response must be concise. 1.02. What is the ratio of the Emissions(in percent) of Korea (Democratic) in 2004 to that in 2005?
Ensure brevity in your answer.  0.99. What is the ratio of the Emissions(in percent) of Mexico in 2004 to that in 2005?
Provide a short and direct response. 0.84. What is the ratio of the Emissions(in percent) in Philippines in 2004 to that in 2005?
Make the answer very short. 0.87. What is the ratio of the Emissions(in percent) in Heavily indebted poor countries in 2004 to that in 2006?
Your response must be concise. 1.15. What is the ratio of the Emissions(in percent) of Korea (Democratic) in 2004 to that in 2006?
Give a very brief answer. 0.98. What is the ratio of the Emissions(in percent) in Mexico in 2004 to that in 2006?
Your answer should be compact. 0.86. What is the ratio of the Emissions(in percent) of Philippines in 2004 to that in 2006?
Offer a terse response. 0.83. What is the ratio of the Emissions(in percent) of Heavily indebted poor countries in 2005 to that in 2006?
Keep it short and to the point. 1.13. What is the ratio of the Emissions(in percent) of Mexico in 2005 to that in 2006?
Give a very brief answer. 1.02. What is the ratio of the Emissions(in percent) of Philippines in 2005 to that in 2006?
Ensure brevity in your answer.  0.96. What is the difference between the highest and the second highest Emissions(in percent) of Heavily indebted poor countries?
Your response must be concise. 0.18. What is the difference between the highest and the second highest Emissions(in percent) of Korea (Democratic)?
Provide a short and direct response. 0.66. What is the difference between the highest and the second highest Emissions(in percent) in Mexico?
Ensure brevity in your answer.  0.12. What is the difference between the highest and the second highest Emissions(in percent) of Philippines?
Make the answer very short. 1.18. What is the difference between the highest and the lowest Emissions(in percent) of Heavily indebted poor countries?
Keep it short and to the point. 0.58. What is the difference between the highest and the lowest Emissions(in percent) in Korea (Democratic)?
Ensure brevity in your answer.  1.85. What is the difference between the highest and the lowest Emissions(in percent) in Mexico?
Offer a terse response. 2.01. What is the difference between the highest and the lowest Emissions(in percent) of Philippines?
Your answer should be very brief. 6.23. 